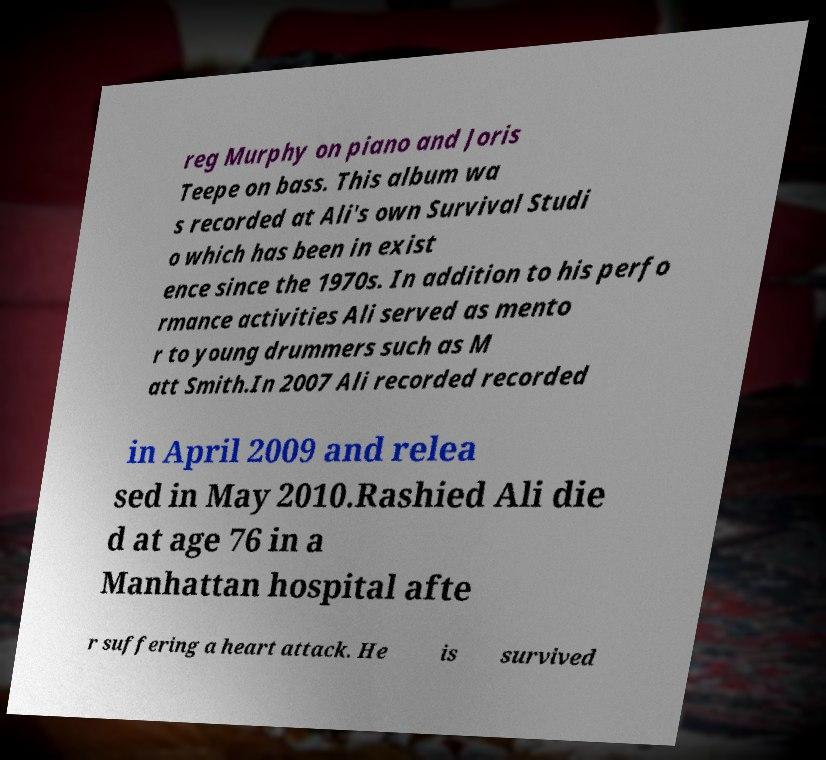Please identify and transcribe the text found in this image. reg Murphy on piano and Joris Teepe on bass. This album wa s recorded at Ali's own Survival Studi o which has been in exist ence since the 1970s. In addition to his perfo rmance activities Ali served as mento r to young drummers such as M att Smith.In 2007 Ali recorded recorded in April 2009 and relea sed in May 2010.Rashied Ali die d at age 76 in a Manhattan hospital afte r suffering a heart attack. He is survived 